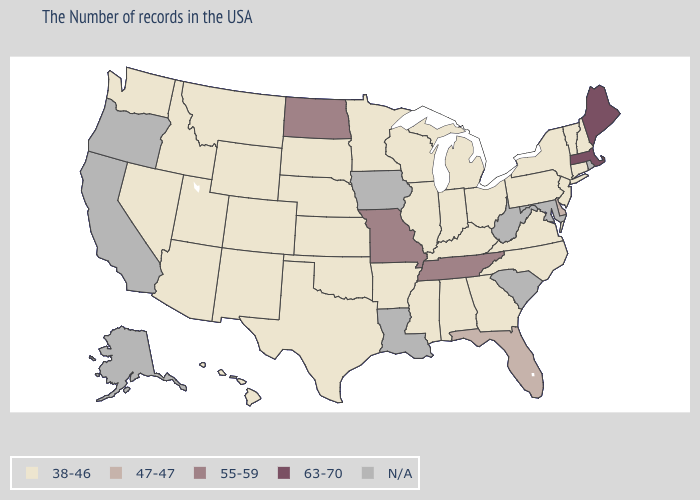Name the states that have a value in the range 38-46?
Give a very brief answer. New Hampshire, Vermont, Connecticut, New York, New Jersey, Pennsylvania, Virginia, North Carolina, Ohio, Georgia, Michigan, Kentucky, Indiana, Alabama, Wisconsin, Illinois, Mississippi, Arkansas, Minnesota, Kansas, Nebraska, Oklahoma, Texas, South Dakota, Wyoming, Colorado, New Mexico, Utah, Montana, Arizona, Idaho, Nevada, Washington, Hawaii. Name the states that have a value in the range N/A?
Give a very brief answer. Rhode Island, Maryland, South Carolina, West Virginia, Louisiana, Iowa, California, Oregon, Alaska. Does the map have missing data?
Short answer required. Yes. How many symbols are there in the legend?
Short answer required. 5. Name the states that have a value in the range 63-70?
Concise answer only. Maine, Massachusetts. What is the value of Colorado?
Short answer required. 38-46. What is the value of Maryland?
Be succinct. N/A. What is the lowest value in the USA?
Concise answer only. 38-46. What is the highest value in the MidWest ?
Quick response, please. 55-59. Among the states that border Massachusetts , which have the highest value?
Concise answer only. New Hampshire, Vermont, Connecticut, New York. What is the value of Minnesota?
Concise answer only. 38-46. Does the first symbol in the legend represent the smallest category?
Give a very brief answer. Yes. Which states have the lowest value in the USA?
Be succinct. New Hampshire, Vermont, Connecticut, New York, New Jersey, Pennsylvania, Virginia, North Carolina, Ohio, Georgia, Michigan, Kentucky, Indiana, Alabama, Wisconsin, Illinois, Mississippi, Arkansas, Minnesota, Kansas, Nebraska, Oklahoma, Texas, South Dakota, Wyoming, Colorado, New Mexico, Utah, Montana, Arizona, Idaho, Nevada, Washington, Hawaii. 